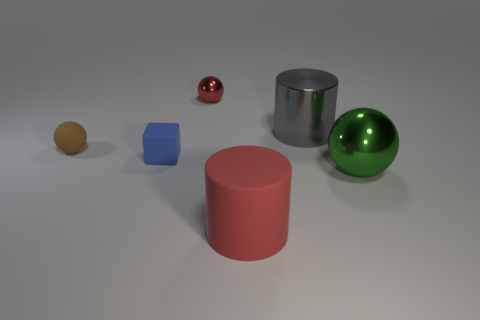Pretend these are objects in a video game. How would you describe their potential uses to a player? In a video game, these objects could serve various purposes. The sphere could be a collectible item or part of a puzzle where it needs to be rolled into a specific location. The cube might be a building block for constructing structures or crafting. The cylinders could act as containers or pedestals for game elements, while their color and shine might indicate rarity or value. 